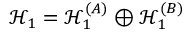<formula> <loc_0><loc_0><loc_500><loc_500>\mathcal { H } _ { 1 } = \mathcal { H } _ { 1 } ^ { ( A ) } \oplus \mathcal { H } _ { 1 } ^ { ( B ) }</formula> 